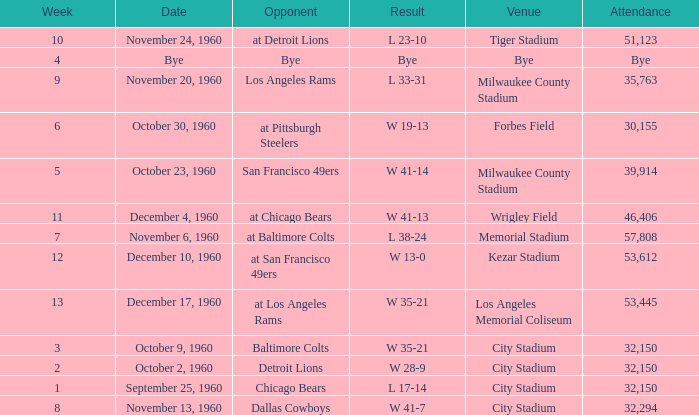What number of people went to the tiger stadium L 23-10. 